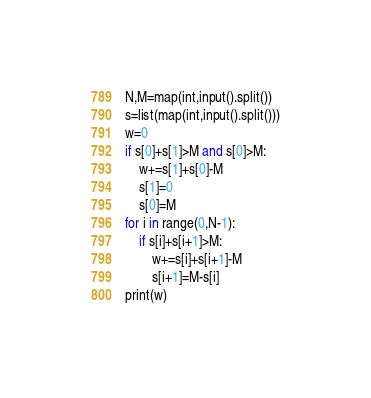<code> <loc_0><loc_0><loc_500><loc_500><_Python_>N,M=map(int,input().split())
s=list(map(int,input().split()))
w=0
if s[0]+s[1]>M and s[0]>M:
    w+=s[1]+s[0]-M
    s[1]=0
    s[0]=M
for i in range(0,N-1):
    if s[i]+s[i+1]>M:
        w+=s[i]+s[i+1]-M
        s[i+1]=M-s[i]
print(w)        </code> 